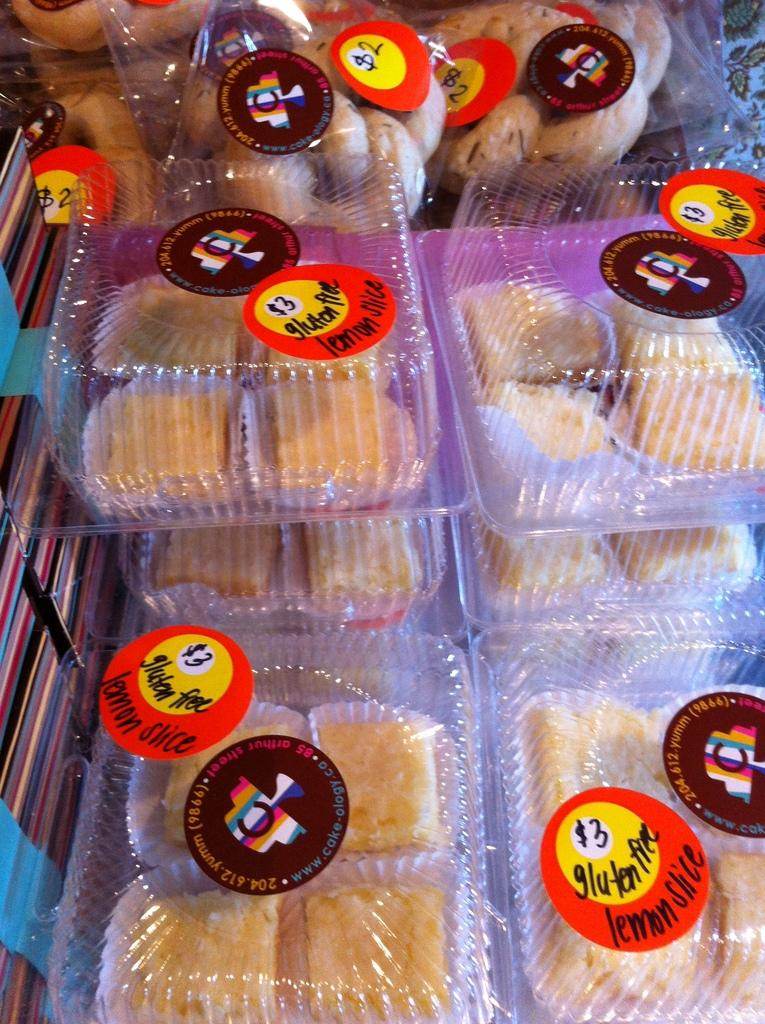What is inside the boxes in the image? There are snacks in the boxes in the image. How are the boxes decorated or labeled in the image? There are stickers pasted on the boxes in the image. What color is the orange gate in the image? There is no orange gate present in the image. 